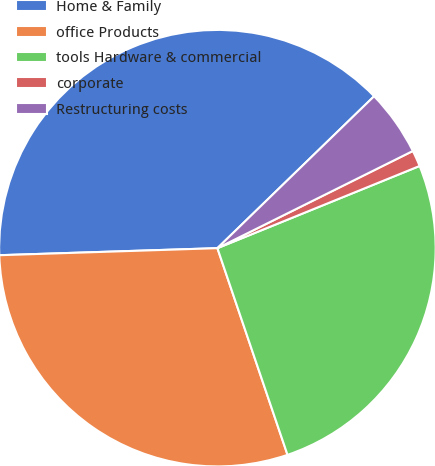Convert chart to OTSL. <chart><loc_0><loc_0><loc_500><loc_500><pie_chart><fcel>Home & Family<fcel>office Products<fcel>tools Hardware & commercial<fcel>corporate<fcel>Restructuring costs<nl><fcel>38.26%<fcel>29.69%<fcel>25.94%<fcel>1.2%<fcel>4.91%<nl></chart> 